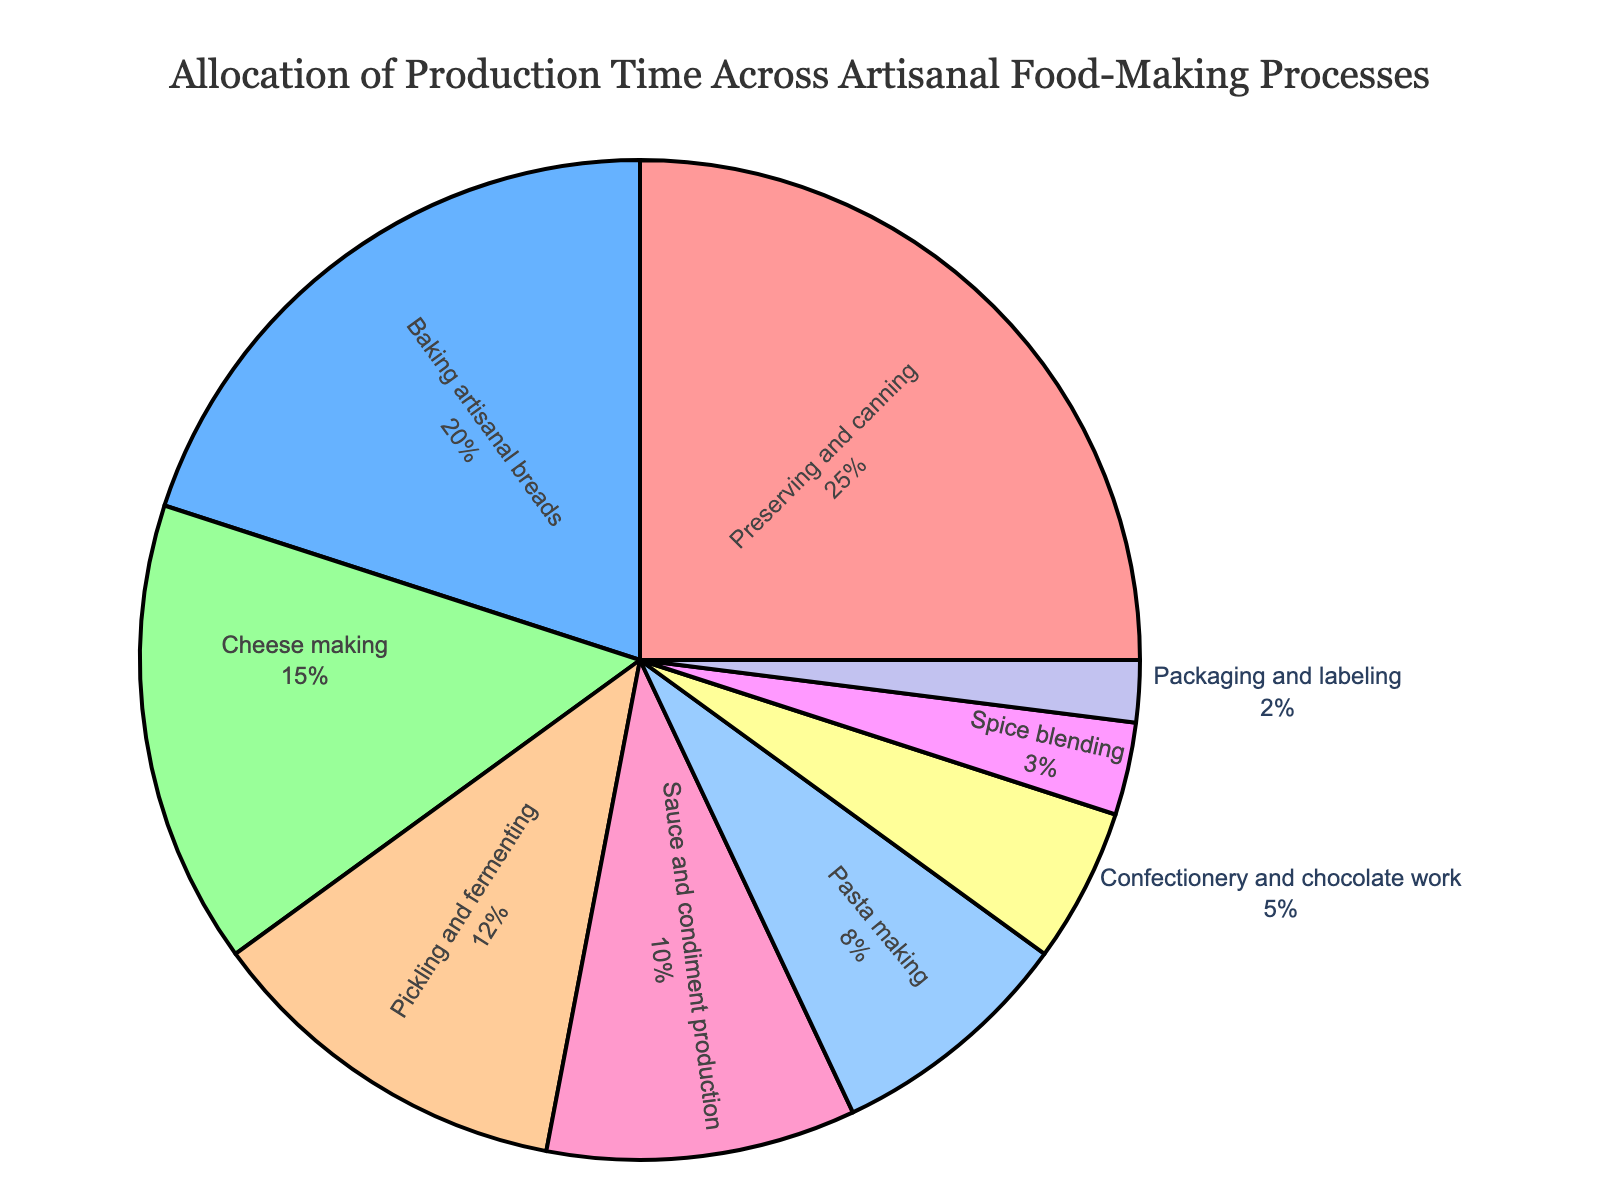Which artisanal food-making process takes the most production time? By looking at the pie chart, identify the process with the largest segment. This is the process that occupies the greatest share of the pie chart.
Answer: Preserving and canning How much more time is spent on cheese making compared to spice blending? Compare the time allocation values for cheese making (15) and spice blending (3) and calculate the difference: 15 - 3.
Answer: 12 What percentage of the total production time is spent on baking artisanal breads? Locate the segment labeled "Baking artisanal breads" on the pie chart and read the percentage value indicated within the segment.
Answer: 20% If you combine the time spent on pasta making, sauce and condiment production, and packaging and labeling, what is the total time allocation? Add the time allocation values for pasta making (8), sauce and condiment production (10), and packaging and labeling (2): 8 + 10 + 2.
Answer: 20 Is the time allocated to pickling and fermenting greater than or less than the time allocated to confectionery and chocolate work? Compare the values of pickling and fermenting (12) and confectionery and chocolate work (5) to determine which is greater.
Answer: Greater Which process has the smallest allocation of production time? Find the segment on the pie chart with the smallest percentage to identify the process with the least time allocation.
Answer: Packaging and labeling What is the combined percentage of the total production time for preserving and canning, and baking artisanal breads? Add the percentage values for preserving and canning (25%) and baking artisanal breads (20%) based on the pie chart labels: 25 + 20.
Answer: 45% How does the production time for sauce and condiment production compare to cheese making? Compare the time allocation values for sauce and condiment production (10) and cheese making (15) to see which is higher.
Answer: Less Is the time spent on pickling and fermenting more or less than half of the time spent on preserving and canning? Compare half of the time allocation for preserving and canning (25 ÷ 2 = 12.5) with the time allocation for pickling and fermenting (12) to determine the relationship.
Answer: Less 